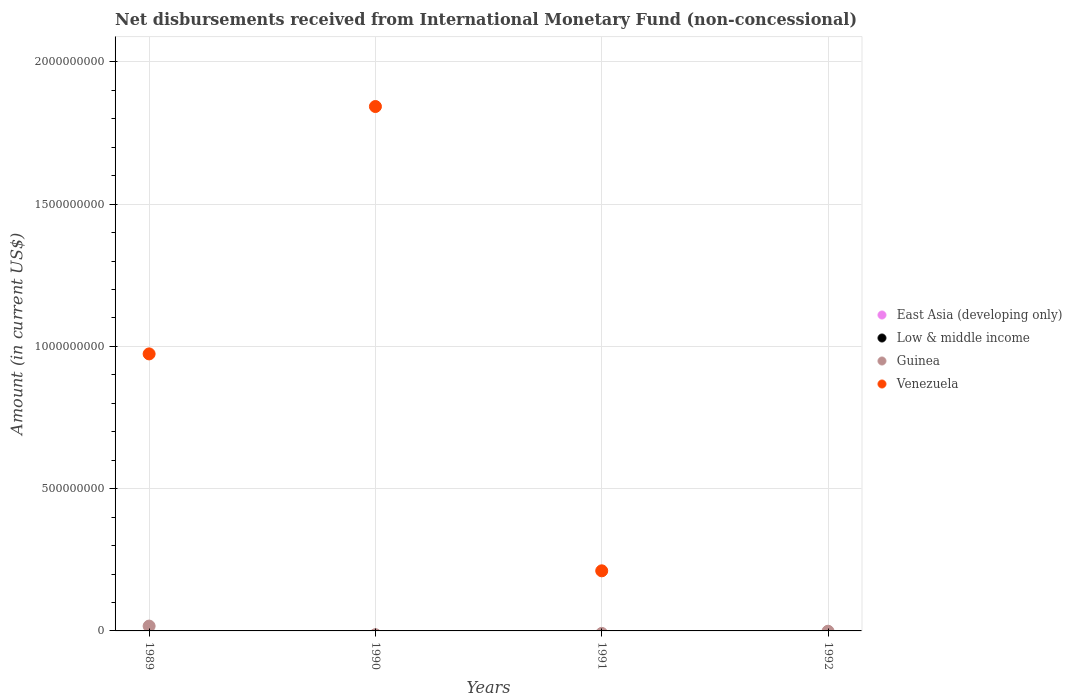Is the number of dotlines equal to the number of legend labels?
Offer a very short reply. No. Across all years, what is the maximum amount of disbursements received from International Monetary Fund in Venezuela?
Provide a short and direct response. 1.84e+09. Across all years, what is the minimum amount of disbursements received from International Monetary Fund in Low & middle income?
Give a very brief answer. 0. In which year was the amount of disbursements received from International Monetary Fund in Guinea maximum?
Keep it short and to the point. 1989. What is the total amount of disbursements received from International Monetary Fund in East Asia (developing only) in the graph?
Offer a very short reply. 0. What is the difference between the amount of disbursements received from International Monetary Fund in Venezuela in 1989 and that in 1990?
Your response must be concise. -8.69e+08. What is the difference between the amount of disbursements received from International Monetary Fund in East Asia (developing only) in 1989 and the amount of disbursements received from International Monetary Fund in Venezuela in 1990?
Offer a terse response. -1.84e+09. What is the average amount of disbursements received from International Monetary Fund in Venezuela per year?
Give a very brief answer. 7.57e+08. What is the ratio of the amount of disbursements received from International Monetary Fund in Venezuela in 1989 to that in 1991?
Ensure brevity in your answer.  4.61. What is the difference between the highest and the lowest amount of disbursements received from International Monetary Fund in Venezuela?
Keep it short and to the point. 1.84e+09. Is it the case that in every year, the sum of the amount of disbursements received from International Monetary Fund in Venezuela and amount of disbursements received from International Monetary Fund in Guinea  is greater than the sum of amount of disbursements received from International Monetary Fund in Low & middle income and amount of disbursements received from International Monetary Fund in East Asia (developing only)?
Keep it short and to the point. No. Does the amount of disbursements received from International Monetary Fund in Guinea monotonically increase over the years?
Provide a short and direct response. No. Is the amount of disbursements received from International Monetary Fund in Venezuela strictly greater than the amount of disbursements received from International Monetary Fund in Guinea over the years?
Your answer should be very brief. No. How many dotlines are there?
Your answer should be very brief. 2. How many years are there in the graph?
Offer a terse response. 4. What is the difference between two consecutive major ticks on the Y-axis?
Ensure brevity in your answer.  5.00e+08. Are the values on the major ticks of Y-axis written in scientific E-notation?
Offer a terse response. No. Does the graph contain grids?
Ensure brevity in your answer.  Yes. How are the legend labels stacked?
Make the answer very short. Vertical. What is the title of the graph?
Offer a terse response. Net disbursements received from International Monetary Fund (non-concessional). What is the Amount (in current US$) in Low & middle income in 1989?
Offer a terse response. 0. What is the Amount (in current US$) of Guinea in 1989?
Offer a very short reply. 1.70e+07. What is the Amount (in current US$) of Venezuela in 1989?
Provide a short and direct response. 9.74e+08. What is the Amount (in current US$) of Low & middle income in 1990?
Your answer should be compact. 0. What is the Amount (in current US$) of Guinea in 1990?
Your response must be concise. 0. What is the Amount (in current US$) in Venezuela in 1990?
Keep it short and to the point. 1.84e+09. What is the Amount (in current US$) in Guinea in 1991?
Your answer should be compact. 0. What is the Amount (in current US$) in Venezuela in 1991?
Keep it short and to the point. 2.11e+08. What is the Amount (in current US$) in Venezuela in 1992?
Ensure brevity in your answer.  0. Across all years, what is the maximum Amount (in current US$) in Guinea?
Give a very brief answer. 1.70e+07. Across all years, what is the maximum Amount (in current US$) of Venezuela?
Offer a terse response. 1.84e+09. Across all years, what is the minimum Amount (in current US$) of Venezuela?
Give a very brief answer. 0. What is the total Amount (in current US$) in East Asia (developing only) in the graph?
Make the answer very short. 0. What is the total Amount (in current US$) of Guinea in the graph?
Provide a short and direct response. 1.70e+07. What is the total Amount (in current US$) of Venezuela in the graph?
Ensure brevity in your answer.  3.03e+09. What is the difference between the Amount (in current US$) in Venezuela in 1989 and that in 1990?
Your answer should be compact. -8.69e+08. What is the difference between the Amount (in current US$) of Venezuela in 1989 and that in 1991?
Your answer should be very brief. 7.62e+08. What is the difference between the Amount (in current US$) of Venezuela in 1990 and that in 1991?
Provide a short and direct response. 1.63e+09. What is the difference between the Amount (in current US$) in Guinea in 1989 and the Amount (in current US$) in Venezuela in 1990?
Ensure brevity in your answer.  -1.83e+09. What is the difference between the Amount (in current US$) of Guinea in 1989 and the Amount (in current US$) of Venezuela in 1991?
Keep it short and to the point. -1.94e+08. What is the average Amount (in current US$) in East Asia (developing only) per year?
Provide a short and direct response. 0. What is the average Amount (in current US$) in Guinea per year?
Your answer should be very brief. 4.24e+06. What is the average Amount (in current US$) of Venezuela per year?
Give a very brief answer. 7.57e+08. In the year 1989, what is the difference between the Amount (in current US$) of Guinea and Amount (in current US$) of Venezuela?
Your answer should be compact. -9.57e+08. What is the ratio of the Amount (in current US$) in Venezuela in 1989 to that in 1990?
Make the answer very short. 0.53. What is the ratio of the Amount (in current US$) in Venezuela in 1989 to that in 1991?
Ensure brevity in your answer.  4.61. What is the ratio of the Amount (in current US$) in Venezuela in 1990 to that in 1991?
Keep it short and to the point. 8.72. What is the difference between the highest and the second highest Amount (in current US$) of Venezuela?
Offer a terse response. 8.69e+08. What is the difference between the highest and the lowest Amount (in current US$) of Guinea?
Make the answer very short. 1.70e+07. What is the difference between the highest and the lowest Amount (in current US$) in Venezuela?
Provide a succinct answer. 1.84e+09. 